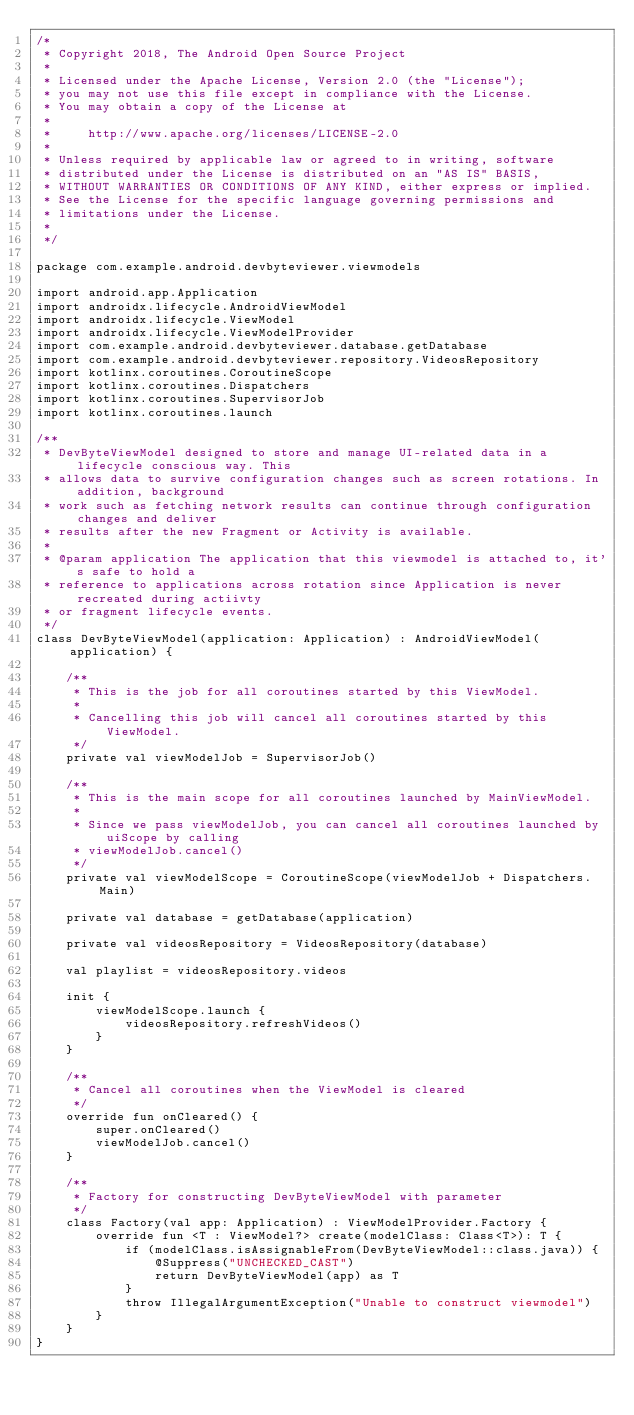Convert code to text. <code><loc_0><loc_0><loc_500><loc_500><_Kotlin_>/*
 * Copyright 2018, The Android Open Source Project
 *
 * Licensed under the Apache License, Version 2.0 (the "License");
 * you may not use this file except in compliance with the License.
 * You may obtain a copy of the License at
 *
 *     http://www.apache.org/licenses/LICENSE-2.0
 *
 * Unless required by applicable law or agreed to in writing, software
 * distributed under the License is distributed on an "AS IS" BASIS,
 * WITHOUT WARRANTIES OR CONDITIONS OF ANY KIND, either express or implied.
 * See the License for the specific language governing permissions and
 * limitations under the License.
 *
 */

package com.example.android.devbyteviewer.viewmodels

import android.app.Application
import androidx.lifecycle.AndroidViewModel
import androidx.lifecycle.ViewModel
import androidx.lifecycle.ViewModelProvider
import com.example.android.devbyteviewer.database.getDatabase
import com.example.android.devbyteviewer.repository.VideosRepository
import kotlinx.coroutines.CoroutineScope
import kotlinx.coroutines.Dispatchers
import kotlinx.coroutines.SupervisorJob
import kotlinx.coroutines.launch

/**
 * DevByteViewModel designed to store and manage UI-related data in a lifecycle conscious way. This
 * allows data to survive configuration changes such as screen rotations. In addition, background
 * work such as fetching network results can continue through configuration changes and deliver
 * results after the new Fragment or Activity is available.
 *
 * @param application The application that this viewmodel is attached to, it's safe to hold a
 * reference to applications across rotation since Application is never recreated during actiivty
 * or fragment lifecycle events.
 */
class DevByteViewModel(application: Application) : AndroidViewModel(application) {

    /**
     * This is the job for all coroutines started by this ViewModel.
     *
     * Cancelling this job will cancel all coroutines started by this ViewModel.
     */
    private val viewModelJob = SupervisorJob()

    /**
     * This is the main scope for all coroutines launched by MainViewModel.
     *
     * Since we pass viewModelJob, you can cancel all coroutines launched by uiScope by calling
     * viewModelJob.cancel()
     */
    private val viewModelScope = CoroutineScope(viewModelJob + Dispatchers.Main)

    private val database = getDatabase(application)

    private val videosRepository = VideosRepository(database)

    val playlist = videosRepository.videos

    init {
        viewModelScope.launch {
            videosRepository.refreshVideos()
        }
    }

    /**
     * Cancel all coroutines when the ViewModel is cleared
     */
    override fun onCleared() {
        super.onCleared()
        viewModelJob.cancel()
    }

    /**
     * Factory for constructing DevByteViewModel with parameter
     */
    class Factory(val app: Application) : ViewModelProvider.Factory {
        override fun <T : ViewModel?> create(modelClass: Class<T>): T {
            if (modelClass.isAssignableFrom(DevByteViewModel::class.java)) {
                @Suppress("UNCHECKED_CAST")
                return DevByteViewModel(app) as T
            }
            throw IllegalArgumentException("Unable to construct viewmodel")
        }
    }
}
</code> 